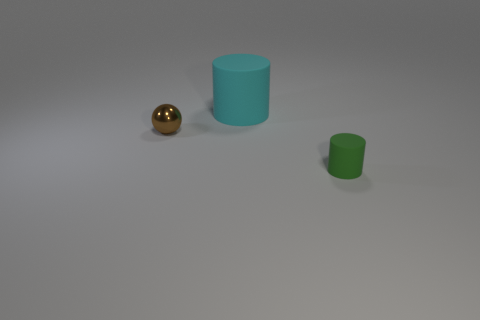Subtract all yellow spheres. Subtract all brown blocks. How many spheres are left? 1 Add 1 green blocks. How many objects exist? 4 Subtract all balls. How many objects are left? 2 Subtract all large cyan objects. Subtract all tiny brown metal balls. How many objects are left? 1 Add 1 green rubber objects. How many green rubber objects are left? 2 Add 1 brown things. How many brown things exist? 2 Subtract 0 gray cylinders. How many objects are left? 3 